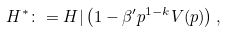Convert formula to latex. <formula><loc_0><loc_0><loc_500><loc_500>H ^ { * } \colon = H | \left ( 1 - \beta ^ { \prime } p ^ { 1 - k } V ( p ) \right ) ,</formula> 